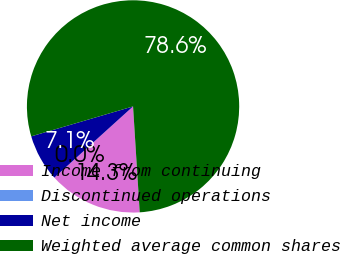Convert chart to OTSL. <chart><loc_0><loc_0><loc_500><loc_500><pie_chart><fcel>Income from continuing<fcel>Discontinued operations<fcel>Net income<fcel>Weighted average common shares<nl><fcel>14.29%<fcel>0.01%<fcel>7.15%<fcel>78.56%<nl></chart> 